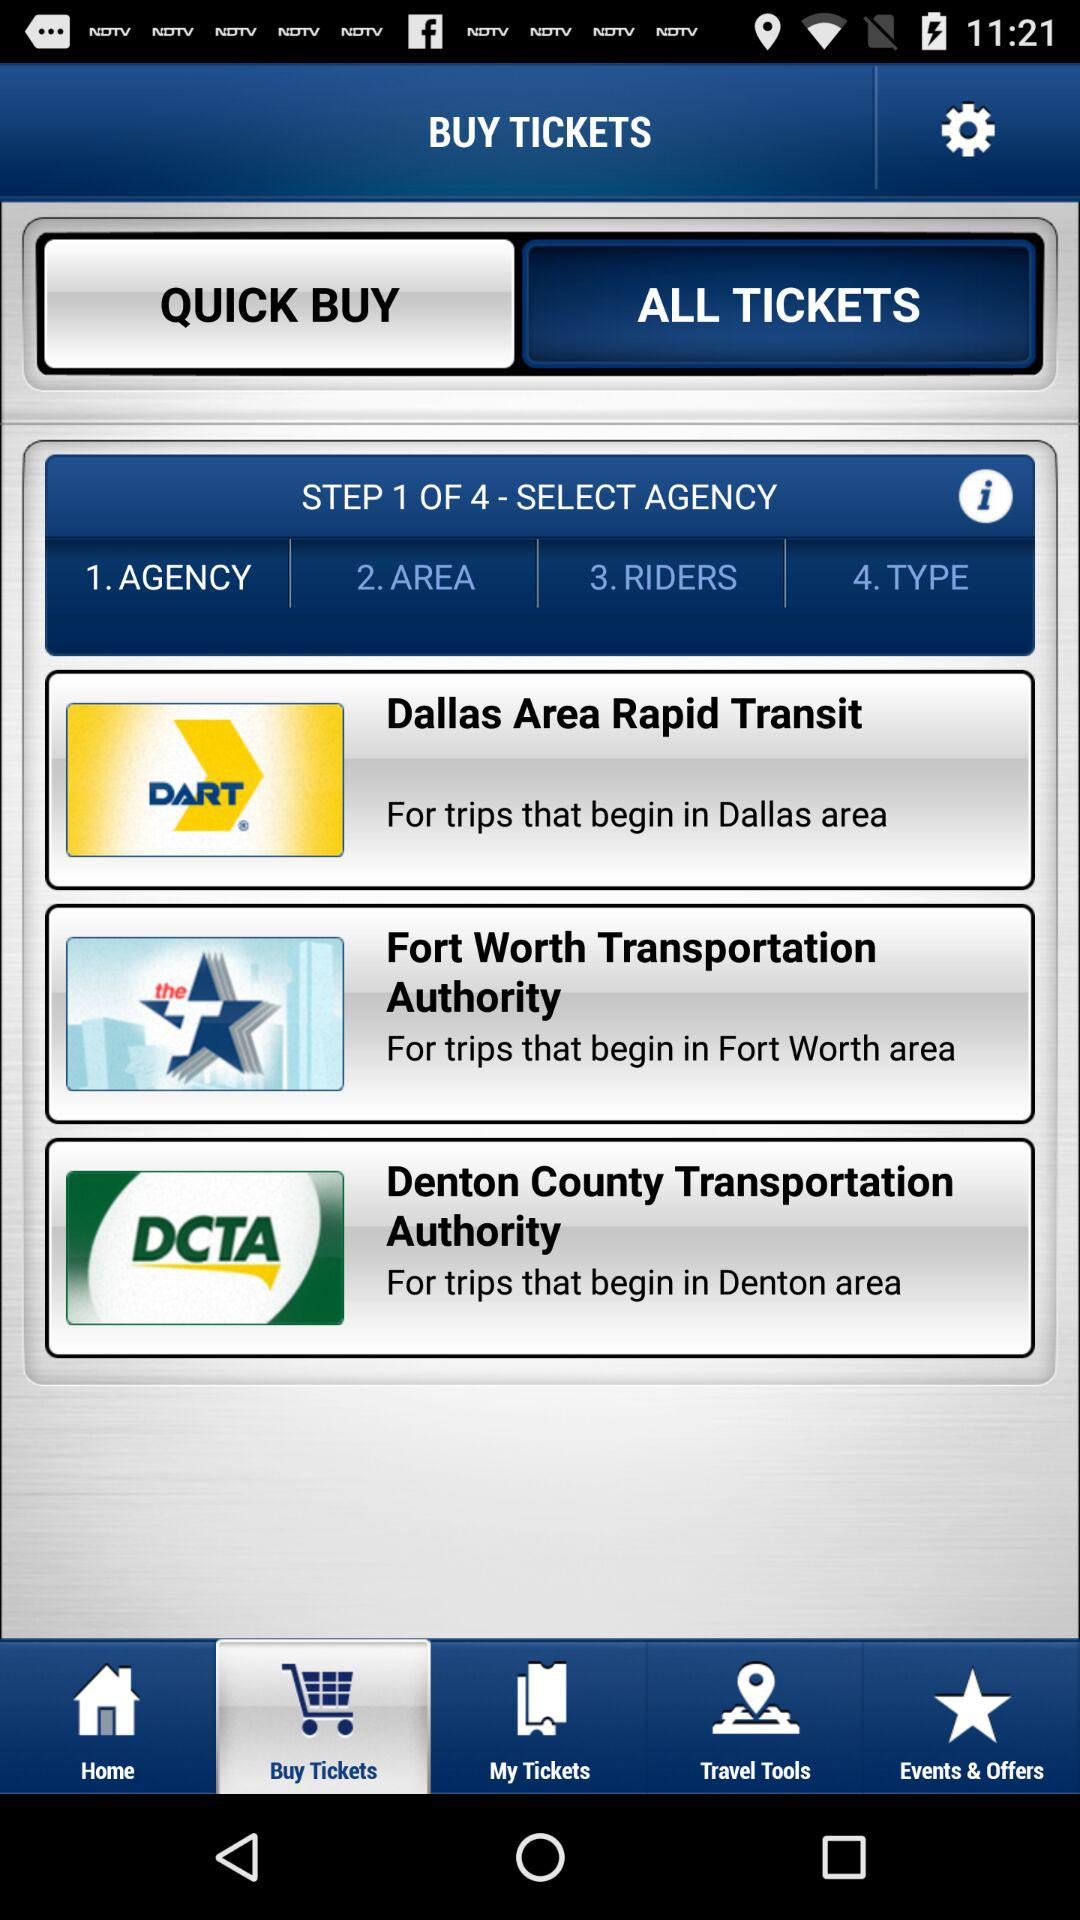Is there a way to buy tickets directly on this platform? Yes, you can purchase tickets directly through this platform. You can tap on the 'Quick Buy' button for a faster purchase experience, or select 'All Tickets' to explore a wider range of ticketing options. 